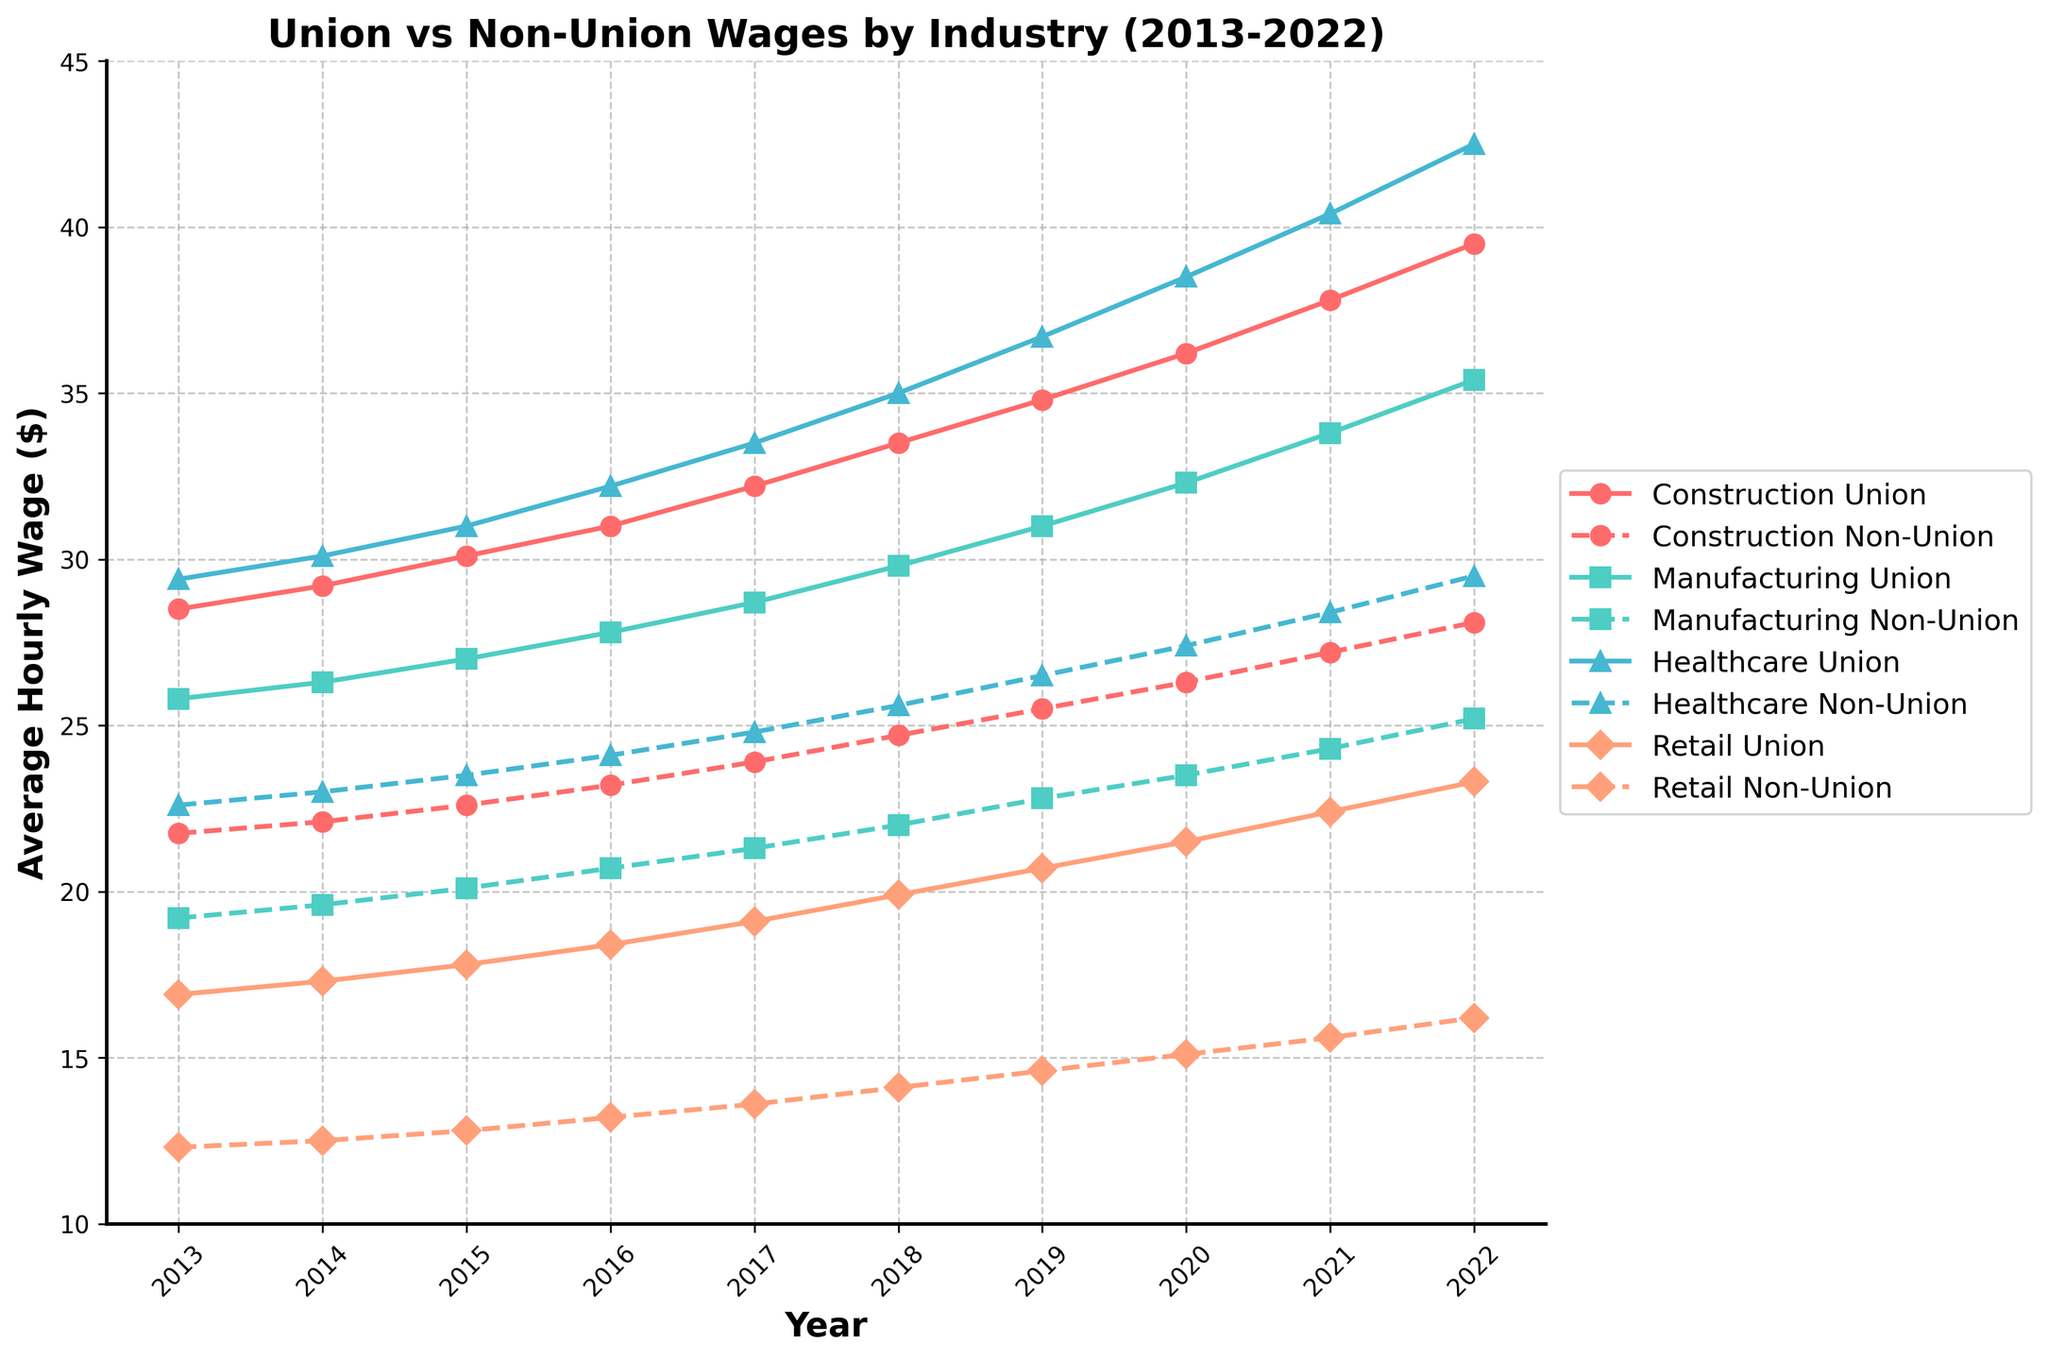Which industry shows the highest average hourly wage for union workers in 2022? Look at the data points for union workers in 2022. Compare the values for all industries: Construction (39.50), Manufacturing (35.40), Healthcare (42.50), and Retail (23.30). The highest value is 42.50 in Healthcare.
Answer: Healthcare Which industry shows the smallest gap in average hourly wage between union and non-union workers in 2020? Calculate the gap between union and non-union wages for each industry in 2020: Construction (36.20 - 26.30 = 9.90), Manufacturing (32.30 - 23.50 = 8.80), Healthcare (38.50 - 27.40 = 11.10), Retail (21.50 - 15.10 = 6.40). The smallest gap is 6.40 in Retail.
Answer: Retail By how much did the average hourly wage for non-union workers in Construction increase from 2013 to 2022? Subtract the 2013 value from the 2022 value for non-union workers in Construction: 28.10 (2022) - 21.75 (2013) = 6.35.
Answer: 6.35 In which year did union workers in Manufacturing first surpass an average hourly wage of $30? Look at the Manufacturing Union data series and find the first year when the value exceeds $30: It first surpassed $30 in 2019 (31.00).
Answer: 2019 What's the average of non-union wages across all industries for the year 2015? Average the non-union wages for all industries in 2015: (22.60 + 20.10 + 23.50 + 12.80) / 4 = 19.75.
Answer: 19.75 What is the difference in average hourly wages between union and non-union workers in the Healthcare industry in 2022? Subtract the non-union wage from the union wage for Healthcare in 2022: 42.50 - 29.50 = 13.00.
Answer: 13.00 In which year did union workers in the Construction industry have an average hourly wage above $30 for the first time? Look at the Construction Union data series and find the first year with a value above $30: It first surpassed $30 in 2015 (30.10).
Answer: 2015 Which industry had the smallest increase in average hourly wage for union workers from 2013 to 2022? Calculate the increase for each industry: Construction (39.50 - 28.50 = 11.00), Manufacturing (35.40 - 25.80 = 9.60), Healthcare (42.50 - 29.40 = 13.10), Retail (23.30 - 16.90 = 6.40). Retail had the smallest increase.
Answer: Retail 